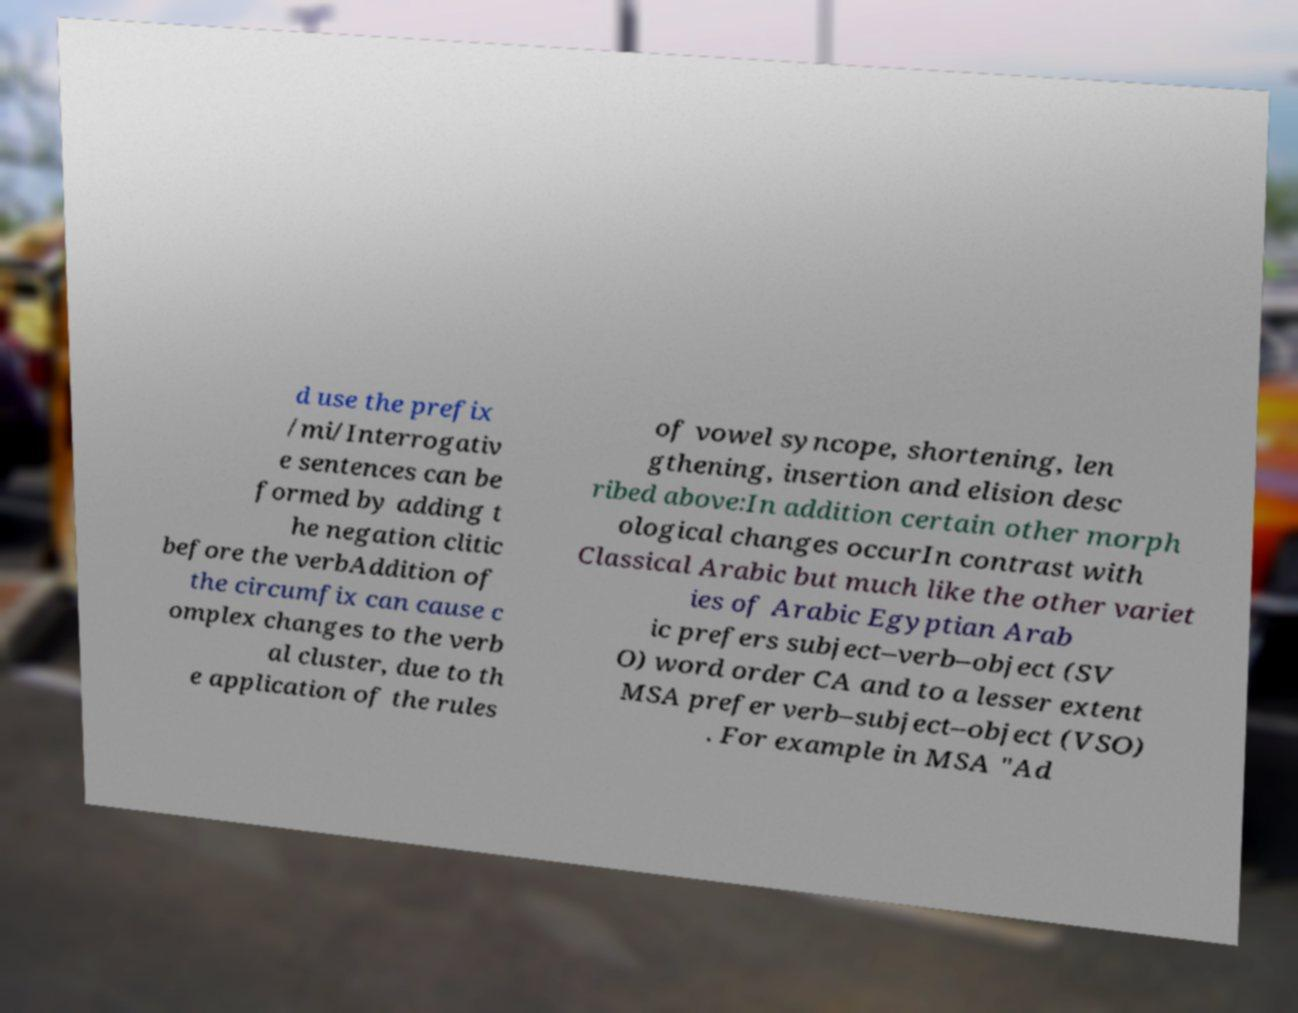For documentation purposes, I need the text within this image transcribed. Could you provide that? d use the prefix /mi/Interrogativ e sentences can be formed by adding t he negation clitic before the verbAddition of the circumfix can cause c omplex changes to the verb al cluster, due to th e application of the rules of vowel syncope, shortening, len gthening, insertion and elision desc ribed above:In addition certain other morph ological changes occurIn contrast with Classical Arabic but much like the other variet ies of Arabic Egyptian Arab ic prefers subject–verb–object (SV O) word order CA and to a lesser extent MSA prefer verb–subject–object (VSO) . For example in MSA "Ad 